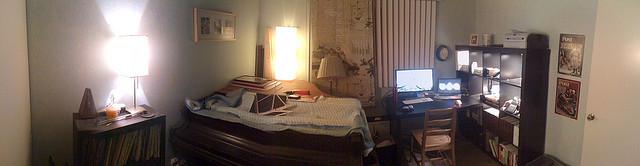Is there a lot of furniture in this room?
Keep it brief. Yes. Do you see a computer on the desk?
Write a very short answer. Yes. Are the computers on?
Write a very short answer. Yes. How many lights are in the picture?
Answer briefly. 2. 